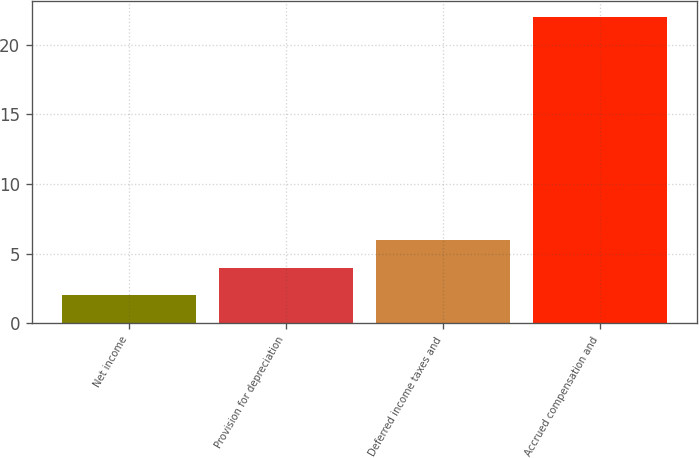<chart> <loc_0><loc_0><loc_500><loc_500><bar_chart><fcel>Net income<fcel>Provision for depreciation<fcel>Deferred income taxes and<fcel>Accrued compensation and<nl><fcel>2<fcel>4<fcel>6<fcel>22<nl></chart> 